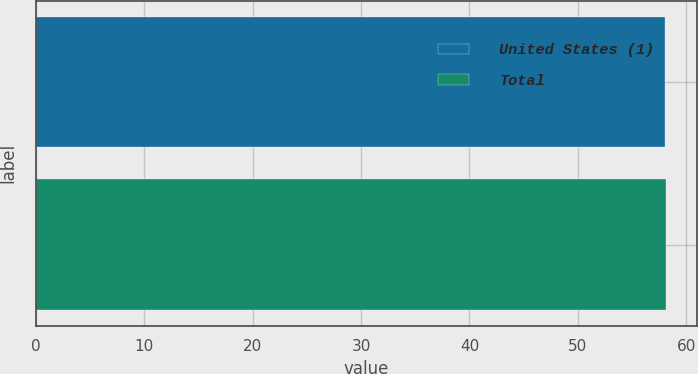Convert chart. <chart><loc_0><loc_0><loc_500><loc_500><bar_chart><fcel>United States (1)<fcel>Total<nl><fcel>58<fcel>58.1<nl></chart> 